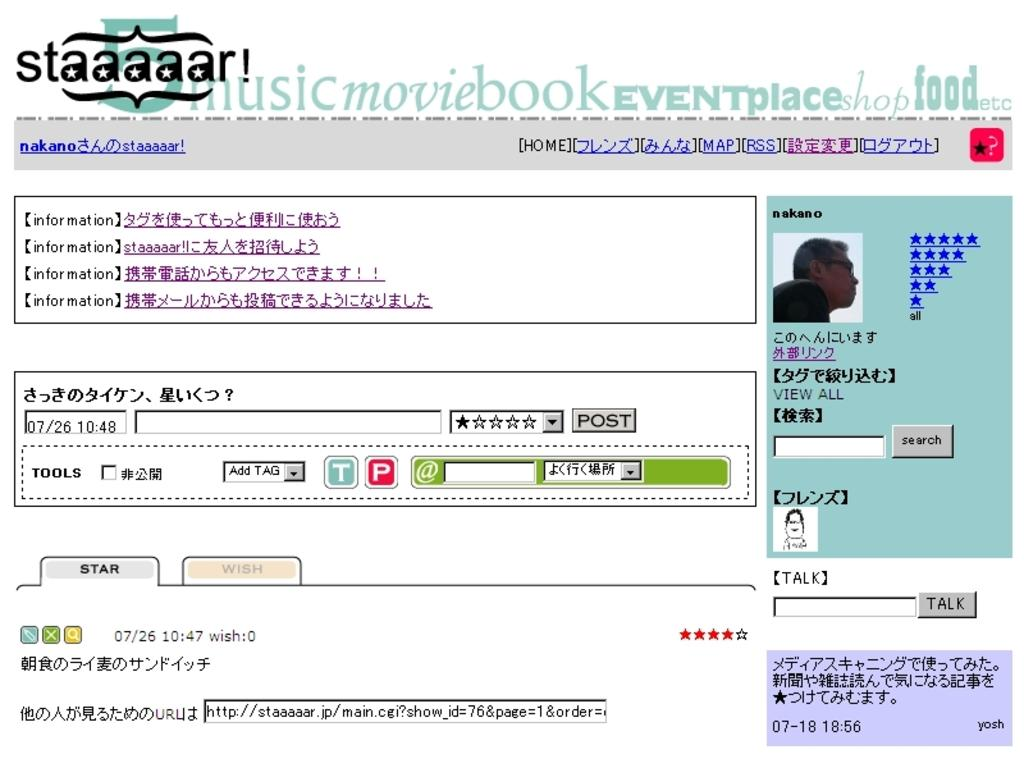What is the medium on which the image is displayed? The image is displayed on a screen. What type of content can be seen in the image? There are texts, buttons, numbers, and fields in the image. What is the color of the background in the image? The background of the image is white. Can you describe any other objects present in the image? There are other objects in the image, but their specific details are not mentioned in the provided facts. How many horses are visible in the image? There are no horses present in the image. What type of hydrant is shown in the image? There is no hydrant present in the image. 